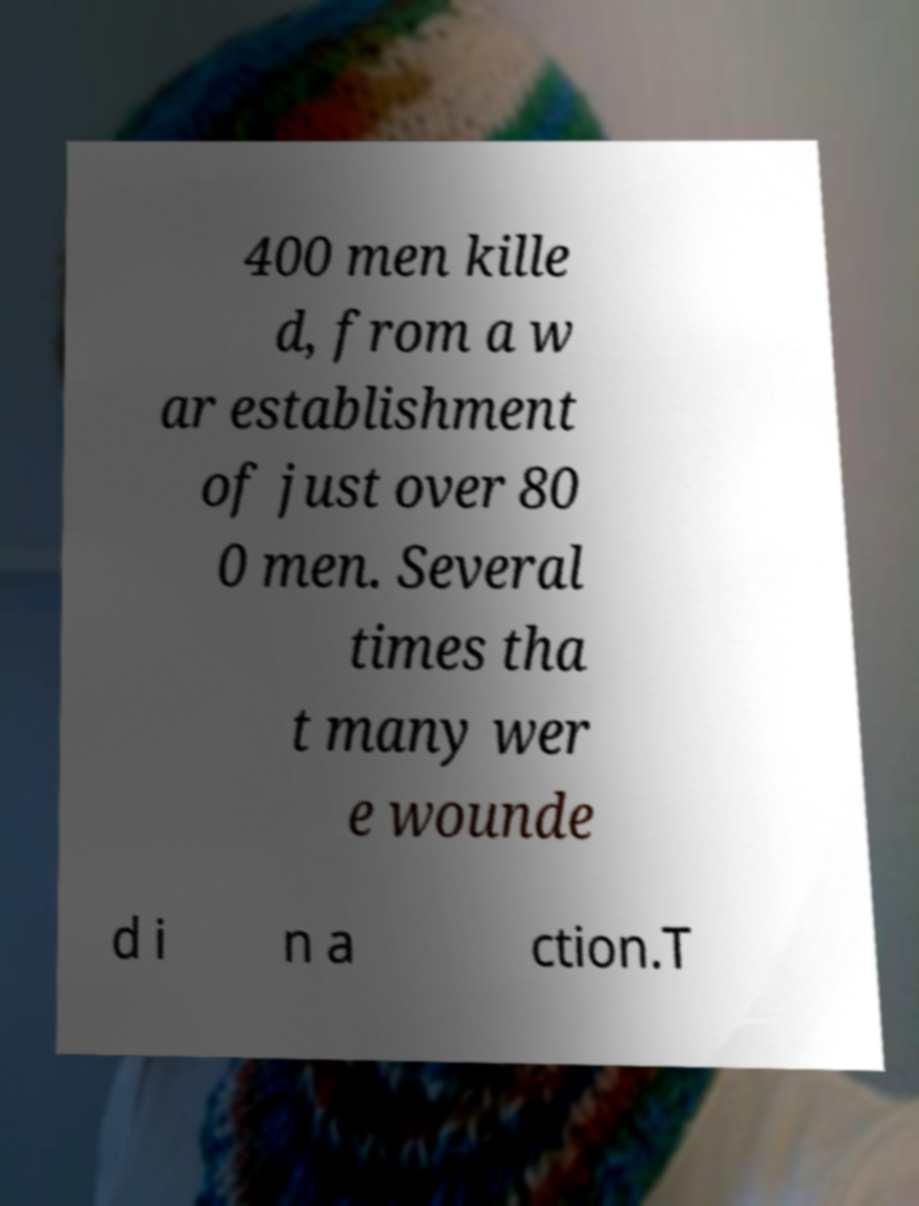Can you read and provide the text displayed in the image?This photo seems to have some interesting text. Can you extract and type it out for me? 400 men kille d, from a w ar establishment of just over 80 0 men. Several times tha t many wer e wounde d i n a ction.T 